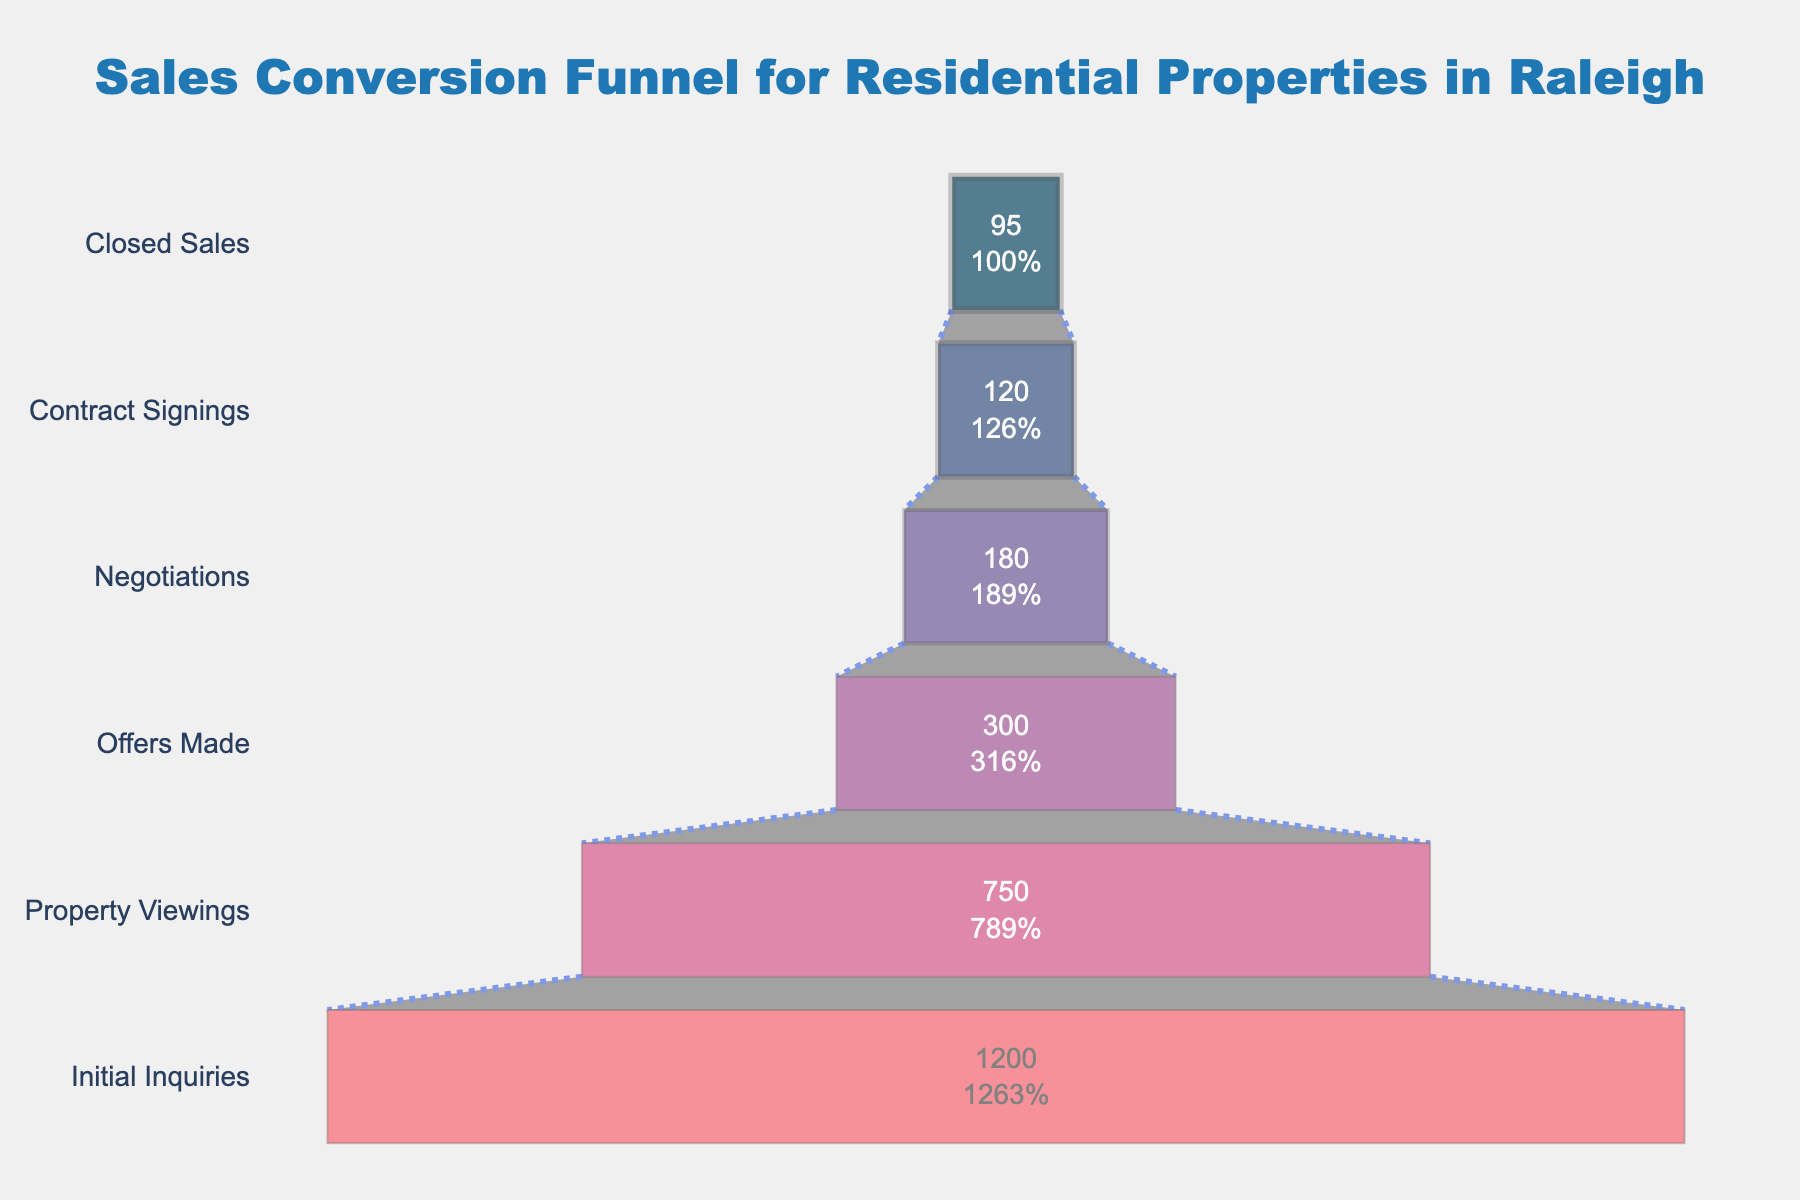What's the title of the funnel chart? The title is usually placed at the top and describes what the chart represents. In this chart, the title is clearly visible in the layout information.
Answer: Sales Conversion Funnel for Residential Properties in Raleigh How many stages are present in the funnel chart? To find the number of stages, count the different levels or segments in the vertical direction. According to the data provided, there are six stages.
Answer: 6 Which stage has the highest number of leads? Look for the widest segment at the top of the funnel chart, as this represents the stage with the largest number of leads. This segment is labeled "Initial Inquiries."
Answer: Initial Inquiries What percentage of initial inquiries resulted in closed sales? First, identify the number of initial inquiries (1200) and the number of closed sales (95). Then divide the number of closed sales by the number of initial inquiries and multiply by 100 to get the percentage: (95 / 1200) * 100.
Answer: 7.92% By how much do the number of property viewings decrease from initial inquiries? Subtract the number of property viewings (750) from the number of initial inquiries (1200): 1200 - 750.
Answer: 450 Which stage has the smallest number of leads? Identify the narrowest segment at the bottom of the funnel chart, as this represents the stage with the fewest number of leads. This segment is labeled "Closed Sales."
Answer: Closed Sales How many stages lose more than half of the leads compared to the previous stage? Compare each stage to the one directly above it. Calculate the loss percentage for each transition and count the number of stages where the loss is more than 50%. The transitions from "Initial Inquiries" to "Property Viewings," and from "Property Viewings" to "Offers Made," both show a loss greater than 50%.
Answer: 2 Between which stages does the conversion rate seem to drop the most? Look for the transition with the largest decrease in leads. Calculate the difference between each pair of stages to identify the largest drop. Calculating for each stage, the largest drop happens between "Initial Inquiries" and "Property Viewings" (450 leads drop).
Answer: Initial Inquiries to Property Viewings What’s the average number of leads across all the stages? Sum up all the leads and then divide by the number of stages: (1200 + 750 + 300 + 180 + 120 + 95) / 6. This equals 2645 / 6.
Answer: 440.83 What color is used for the "Negotiations" stage in the funnel chart? Funnel charts use different colors to represent different stages. Referring to the color sequence in the code, the color for the "Negotiations" stage is "#a05195".
Answer: A shade of purple 